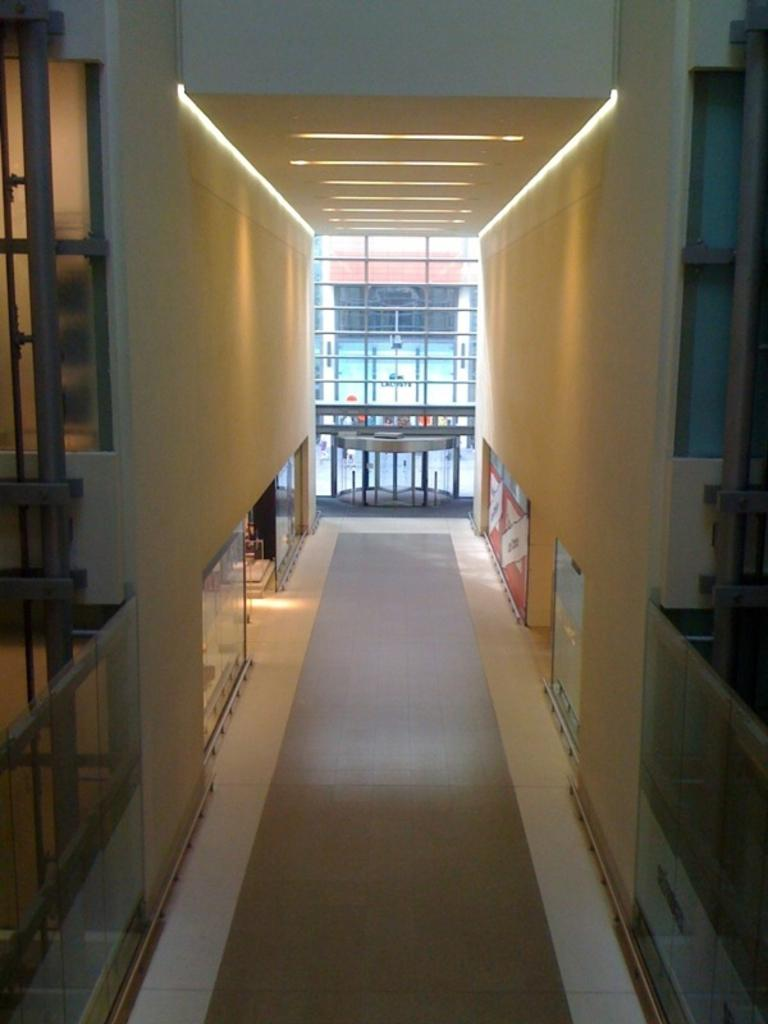What is located on the left side of the image? There is a wall on the left side of the image. What is located on the right side of the image? There is a wall on the right side of the image. What can be seen in the middle of the image? There is a window in the middle of the image. Can you provide any advice from the hen in the image? There is no hen present in the image, so it is not possible to provide advice from a hen. 